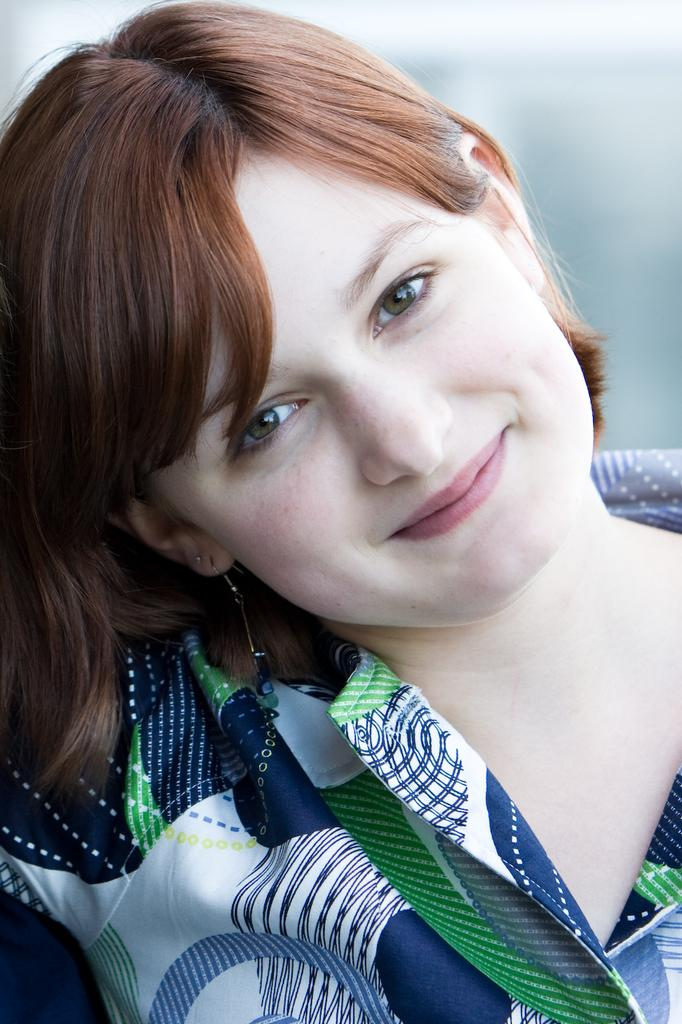What is the main subject of the image? The main subject of the image is a lady. What is the lady wearing in the image? The lady is wearing earrings in the image. What expression does the lady have in the image? The lady is smiling in the image. Can you describe the background of the image? The background of the image is blurred. What type of yarn is the lady holding in the image? There is no yarn present in the image; the lady is not holding any yarn. What type of lunch is the lady eating in the image? There is no lunch present in the image; the lady is not eating anything. What color is the orange that the lady is holding in the image? There is no orange present in the image; the lady is not holding any orange. 